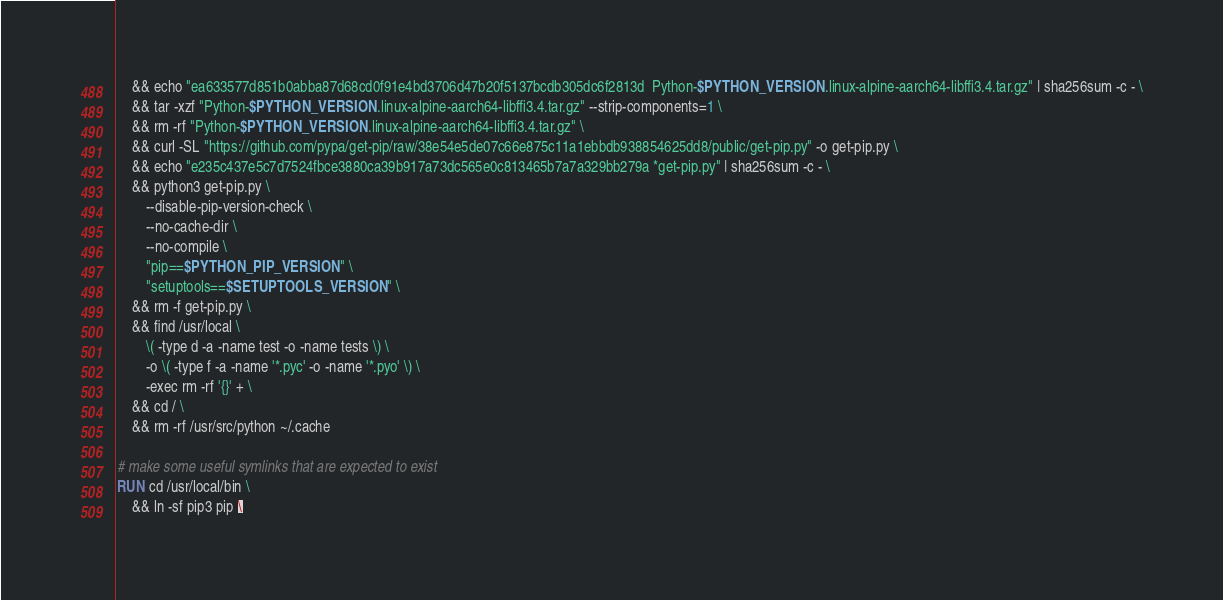Convert code to text. <code><loc_0><loc_0><loc_500><loc_500><_Dockerfile_>	&& echo "ea633577d851b0abba87d68cd0f91e4bd3706d47b20f5137bcdb305dc6f2813d  Python-$PYTHON_VERSION.linux-alpine-aarch64-libffi3.4.tar.gz" | sha256sum -c - \
	&& tar -xzf "Python-$PYTHON_VERSION.linux-alpine-aarch64-libffi3.4.tar.gz" --strip-components=1 \
	&& rm -rf "Python-$PYTHON_VERSION.linux-alpine-aarch64-libffi3.4.tar.gz" \
	&& curl -SL "https://github.com/pypa/get-pip/raw/38e54e5de07c66e875c11a1ebbdb938854625dd8/public/get-pip.py" -o get-pip.py \
    && echo "e235c437e5c7d7524fbce3880ca39b917a73dc565e0c813465b7a7a329bb279a *get-pip.py" | sha256sum -c - \
    && python3 get-pip.py \
        --disable-pip-version-check \
        --no-cache-dir \
        --no-compile \
        "pip==$PYTHON_PIP_VERSION" \
        "setuptools==$SETUPTOOLS_VERSION" \
	&& rm -f get-pip.py \
	&& find /usr/local \
		\( -type d -a -name test -o -name tests \) \
		-o \( -type f -a -name '*.pyc' -o -name '*.pyo' \) \
		-exec rm -rf '{}' + \
	&& cd / \
	&& rm -rf /usr/src/python ~/.cache

# make some useful symlinks that are expected to exist
RUN cd /usr/local/bin \
	&& ln -sf pip3 pip \</code> 